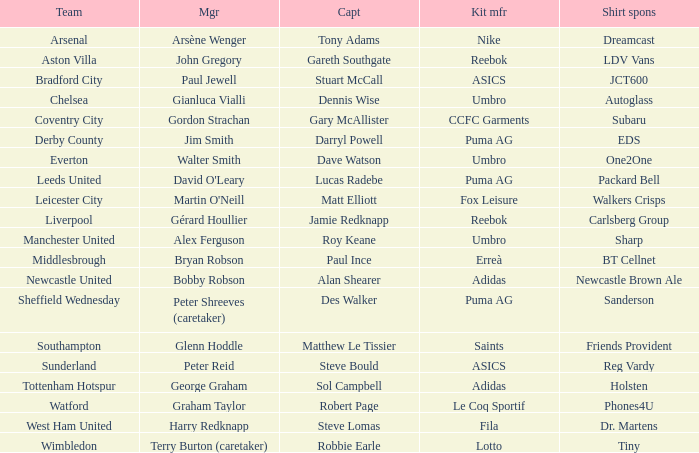Which captain is managed by gianluca vialli? Dennis Wise. 